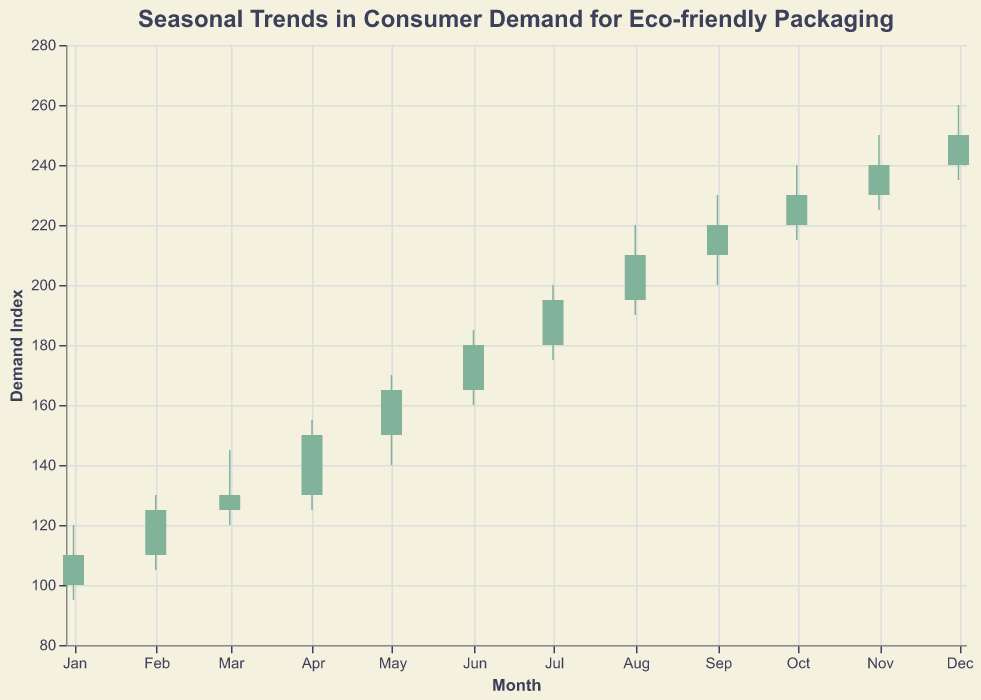Which month shows the highest demand index? The highest demand index is shown by the closing price of the candlestick plot. Among the months, December has the highest closing value of 250.
Answer: December What is the lowest demand index recorded in any month? The lowest demand index is shown by the lowest price of the candlestick plot. In January, the lowest demand index recorded is 95.
Answer: 95 How many months show an increase in demand index from open to close? An increase is indicated by the close being higher than the open. This happens if the color bar is green. There are 12 months shown, each with green bars; thus, all 12 months show an increase.
Answer: 12 Which month has the smallest range in demand index? The smallest range is found by calculating the difference between the high and low for each month and identifying the smallest value. March has the smallest range: 145 - 120 = 25.
Answer: March In which month is the difference between the opening and closing demand index the largest? To find the largest difference, subtract the opening index from the closing index for each month and identify the maximum value. May has the largest difference: 165 - 150 = 15.
Answer: May Does demand generally increase or decrease over the months? The general trend is shown by the concatenated sequence of closing values. From January to December, the closing values consistently increase, indicating an overall increase in demand.
Answer: Increase Which month sees the highest fluctuation in demand index within the month? Highest fluctuation is indicated by the biggest difference between the high and low values. December has the highest fluctuation: 260 - 235 = 25.
Answer: December In which month does the demand index close lower than it opens? This can be seen by noting any month where the color bar is red (signifying a decline). There are no such months as all bars are green, indicating a rise in demand index in all months.
Answer: None What is the average opening demand index for the first quarter (January to March)? Calculate the average by summing the opening values for January, February, and March, then dividing by 3: (100 + 110 + 125)/3 = 335/3.
Answer: 111.67 Which month records the highest peak (high) in demand index? The highest recorded peak is shown by the highest value of the upper wick. December has the highest peak at 260.
Answer: December 